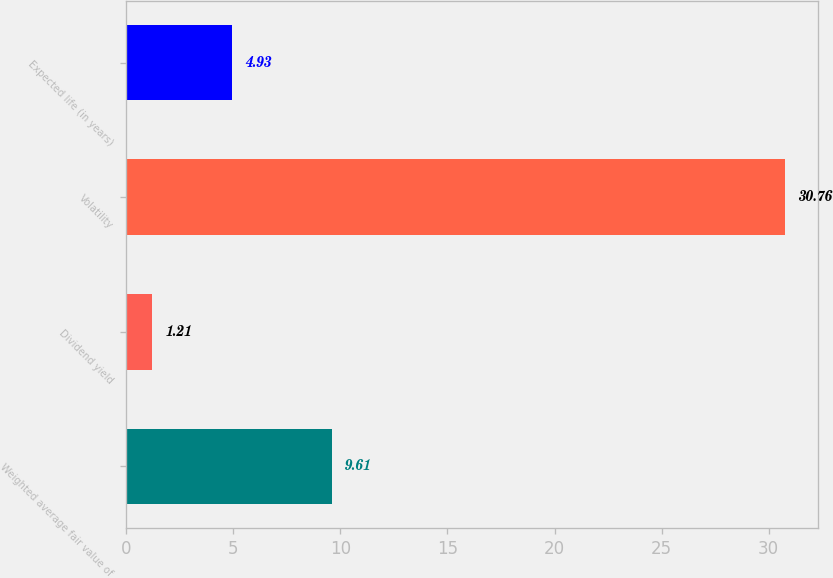Convert chart to OTSL. <chart><loc_0><loc_0><loc_500><loc_500><bar_chart><fcel>Weighted average fair value of<fcel>Dividend yield<fcel>Volatility<fcel>Expected life (in years)<nl><fcel>9.61<fcel>1.21<fcel>30.76<fcel>4.93<nl></chart> 